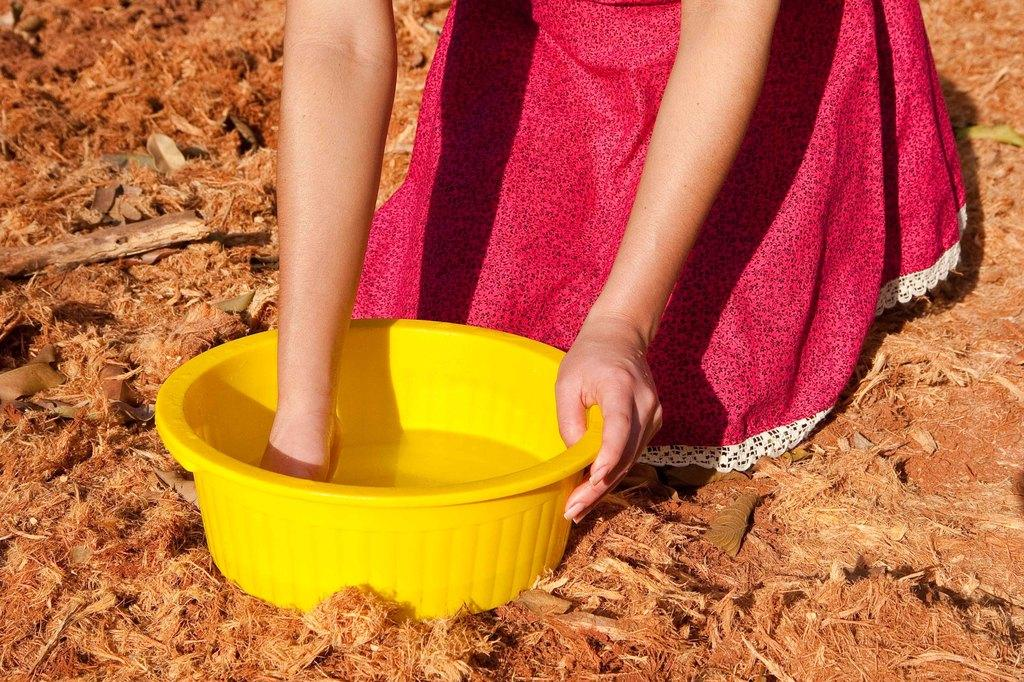What is placed on the floor in the image? There is a water tub on the floor in the image. Can you describe the person in the image? There is a lady at the top side of the image. What is the rate at which the worm is thrilling the lady in the image? There is no worm present in the image, and therefore no such interaction can be observed. 